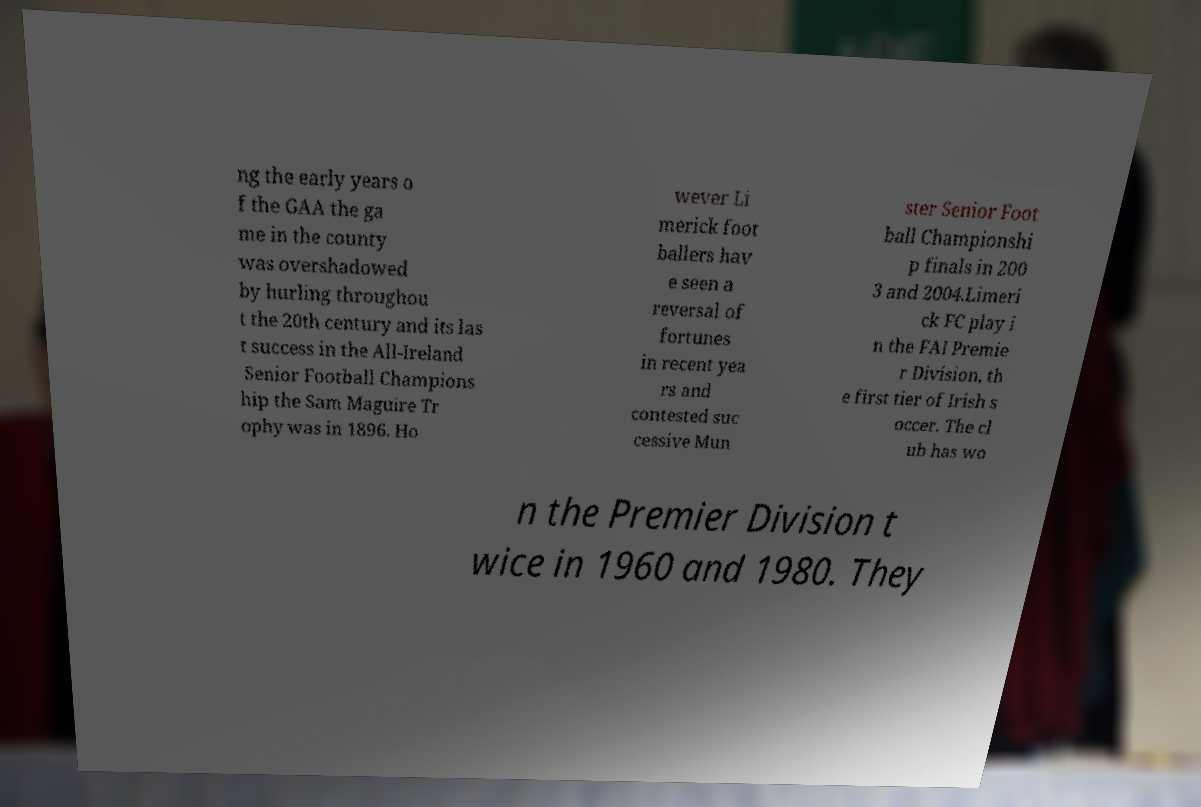Please read and relay the text visible in this image. What does it say? ng the early years o f the GAA the ga me in the county was overshadowed by hurling throughou t the 20th century and its las t success in the All-Ireland Senior Football Champions hip the Sam Maguire Tr ophy was in 1896. Ho wever Li merick foot ballers hav e seen a reversal of fortunes in recent yea rs and contested suc cessive Mun ster Senior Foot ball Championshi p finals in 200 3 and 2004.Limeri ck FC play i n the FAI Premie r Division, th e first tier of Irish s occer. The cl ub has wo n the Premier Division t wice in 1960 and 1980. They 